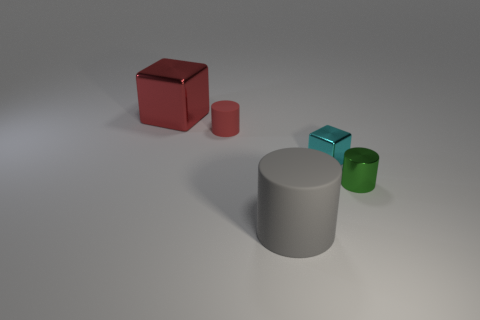Subtract all tiny red matte cylinders. How many cylinders are left? 2 Add 2 rubber cylinders. How many objects exist? 7 Subtract all cyan blocks. How many blocks are left? 1 Subtract all cylinders. How many objects are left? 2 Add 2 large red metal things. How many large red metal things exist? 3 Subtract 0 yellow cubes. How many objects are left? 5 Subtract 3 cylinders. How many cylinders are left? 0 Subtract all yellow blocks. Subtract all yellow cylinders. How many blocks are left? 2 Subtract all tiny red matte things. Subtract all matte things. How many objects are left? 2 Add 2 tiny green metallic objects. How many tiny green metallic objects are left? 3 